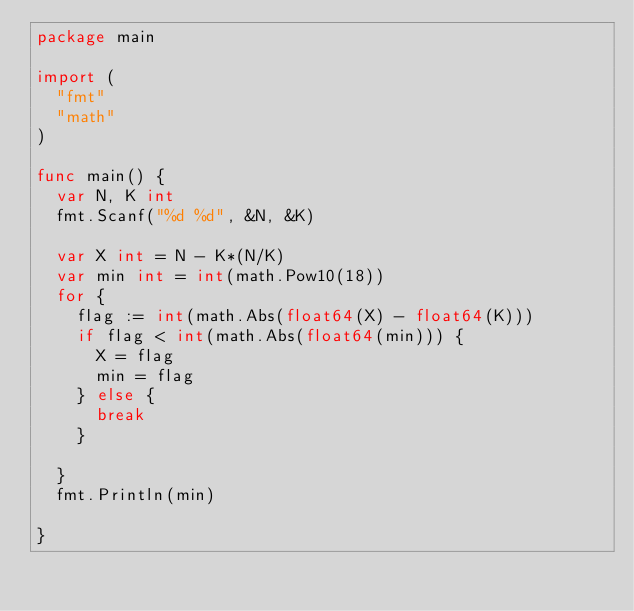Convert code to text. <code><loc_0><loc_0><loc_500><loc_500><_Go_>package main

import (
	"fmt"
	"math"
)

func main() {
	var N, K int
	fmt.Scanf("%d %d", &N, &K)

	var X int = N - K*(N/K)
	var min int = int(math.Pow10(18))
	for {
		flag := int(math.Abs(float64(X) - float64(K)))
		if flag < int(math.Abs(float64(min))) {
			X = flag
			min = flag
		} else {
			break
		}

	}
	fmt.Println(min)

}
</code> 